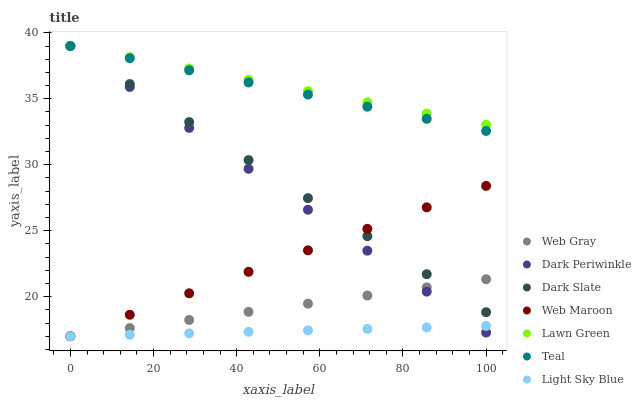Does Light Sky Blue have the minimum area under the curve?
Answer yes or no. Yes. Does Lawn Green have the maximum area under the curve?
Answer yes or no. Yes. Does Web Gray have the minimum area under the curve?
Answer yes or no. No. Does Web Gray have the maximum area under the curve?
Answer yes or no. No. Is Light Sky Blue the smoothest?
Answer yes or no. Yes. Is Dark Periwinkle the roughest?
Answer yes or no. Yes. Is Web Gray the smoothest?
Answer yes or no. No. Is Web Gray the roughest?
Answer yes or no. No. Does Web Gray have the lowest value?
Answer yes or no. Yes. Does Dark Slate have the lowest value?
Answer yes or no. No. Does Dark Periwinkle have the highest value?
Answer yes or no. Yes. Does Web Gray have the highest value?
Answer yes or no. No. Is Web Maroon less than Teal?
Answer yes or no. Yes. Is Lawn Green greater than Web Maroon?
Answer yes or no. Yes. Does Dark Periwinkle intersect Lawn Green?
Answer yes or no. Yes. Is Dark Periwinkle less than Lawn Green?
Answer yes or no. No. Is Dark Periwinkle greater than Lawn Green?
Answer yes or no. No. Does Web Maroon intersect Teal?
Answer yes or no. No. 